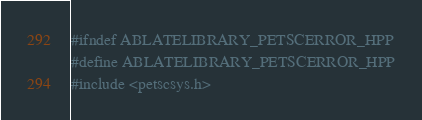Convert code to text. <code><loc_0><loc_0><loc_500><loc_500><_C++_>#ifndef ABLATELIBRARY_PETSCERROR_HPP
#define ABLATELIBRARY_PETSCERROR_HPP
#include <petscsys.h></code> 